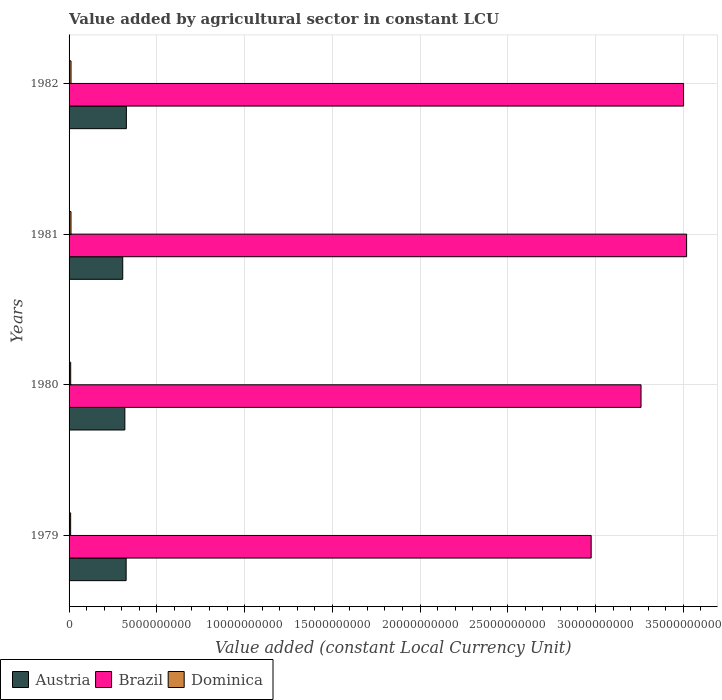How many different coloured bars are there?
Your answer should be compact. 3. How many bars are there on the 4th tick from the top?
Keep it short and to the point. 3. In how many cases, is the number of bars for a given year not equal to the number of legend labels?
Give a very brief answer. 0. What is the value added by agricultural sector in Dominica in 1981?
Ensure brevity in your answer.  1.09e+08. Across all years, what is the maximum value added by agricultural sector in Brazil?
Make the answer very short. 3.52e+1. Across all years, what is the minimum value added by agricultural sector in Dominica?
Your answer should be compact. 8.96e+07. In which year was the value added by agricultural sector in Austria minimum?
Your response must be concise. 1981. What is the total value added by agricultural sector in Brazil in the graph?
Ensure brevity in your answer.  1.33e+11. What is the difference between the value added by agricultural sector in Brazil in 1979 and that in 1980?
Provide a succinct answer. -2.84e+09. What is the difference between the value added by agricultural sector in Brazil in 1980 and the value added by agricultural sector in Dominica in 1979?
Your response must be concise. 3.25e+1. What is the average value added by agricultural sector in Brazil per year?
Your answer should be very brief. 3.31e+1. In the year 1979, what is the difference between the value added by agricultural sector in Brazil and value added by agricultural sector in Austria?
Your answer should be very brief. 2.65e+1. In how many years, is the value added by agricultural sector in Brazil greater than 17000000000 LCU?
Keep it short and to the point. 4. What is the ratio of the value added by agricultural sector in Austria in 1981 to that in 1982?
Make the answer very short. 0.94. Is the value added by agricultural sector in Brazil in 1981 less than that in 1982?
Make the answer very short. No. Is the difference between the value added by agricultural sector in Brazil in 1979 and 1980 greater than the difference between the value added by agricultural sector in Austria in 1979 and 1980?
Make the answer very short. No. What is the difference between the highest and the second highest value added by agricultural sector in Austria?
Your answer should be very brief. 1.25e+07. What is the difference between the highest and the lowest value added by agricultural sector in Dominica?
Make the answer very short. 2.11e+07. What does the 1st bar from the top in 1982 represents?
Keep it short and to the point. Dominica. What does the 2nd bar from the bottom in 1979 represents?
Your response must be concise. Brazil. How many years are there in the graph?
Your response must be concise. 4. Does the graph contain grids?
Keep it short and to the point. Yes. How many legend labels are there?
Ensure brevity in your answer.  3. What is the title of the graph?
Your response must be concise. Value added by agricultural sector in constant LCU. What is the label or title of the X-axis?
Ensure brevity in your answer.  Value added (constant Local Currency Unit). What is the Value added (constant Local Currency Unit) of Austria in 1979?
Make the answer very short. 3.25e+09. What is the Value added (constant Local Currency Unit) in Brazil in 1979?
Your response must be concise. 2.98e+1. What is the Value added (constant Local Currency Unit) of Dominica in 1979?
Provide a short and direct response. 8.96e+07. What is the Value added (constant Local Currency Unit) in Austria in 1980?
Your response must be concise. 3.18e+09. What is the Value added (constant Local Currency Unit) in Brazil in 1980?
Your answer should be compact. 3.26e+1. What is the Value added (constant Local Currency Unit) in Dominica in 1980?
Your response must be concise. 9.17e+07. What is the Value added (constant Local Currency Unit) of Austria in 1981?
Your answer should be very brief. 3.06e+09. What is the Value added (constant Local Currency Unit) in Brazil in 1981?
Your answer should be compact. 3.52e+1. What is the Value added (constant Local Currency Unit) in Dominica in 1981?
Ensure brevity in your answer.  1.09e+08. What is the Value added (constant Local Currency Unit) in Austria in 1982?
Make the answer very short. 3.27e+09. What is the Value added (constant Local Currency Unit) of Brazil in 1982?
Provide a succinct answer. 3.50e+1. What is the Value added (constant Local Currency Unit) in Dominica in 1982?
Your answer should be very brief. 1.11e+08. Across all years, what is the maximum Value added (constant Local Currency Unit) of Austria?
Your response must be concise. 3.27e+09. Across all years, what is the maximum Value added (constant Local Currency Unit) in Brazil?
Offer a terse response. 3.52e+1. Across all years, what is the maximum Value added (constant Local Currency Unit) in Dominica?
Provide a succinct answer. 1.11e+08. Across all years, what is the minimum Value added (constant Local Currency Unit) of Austria?
Provide a succinct answer. 3.06e+09. Across all years, what is the minimum Value added (constant Local Currency Unit) of Brazil?
Your response must be concise. 2.98e+1. Across all years, what is the minimum Value added (constant Local Currency Unit) of Dominica?
Ensure brevity in your answer.  8.96e+07. What is the total Value added (constant Local Currency Unit) in Austria in the graph?
Keep it short and to the point. 1.28e+1. What is the total Value added (constant Local Currency Unit) in Brazil in the graph?
Make the answer very short. 1.33e+11. What is the total Value added (constant Local Currency Unit) of Dominica in the graph?
Provide a short and direct response. 4.01e+08. What is the difference between the Value added (constant Local Currency Unit) in Austria in 1979 and that in 1980?
Provide a short and direct response. 7.33e+07. What is the difference between the Value added (constant Local Currency Unit) in Brazil in 1979 and that in 1980?
Offer a terse response. -2.84e+09. What is the difference between the Value added (constant Local Currency Unit) of Dominica in 1979 and that in 1980?
Make the answer very short. -2.09e+06. What is the difference between the Value added (constant Local Currency Unit) of Austria in 1979 and that in 1981?
Your answer should be compact. 1.94e+08. What is the difference between the Value added (constant Local Currency Unit) in Brazil in 1979 and that in 1981?
Make the answer very short. -5.44e+09. What is the difference between the Value added (constant Local Currency Unit) of Dominica in 1979 and that in 1981?
Ensure brevity in your answer.  -1.97e+07. What is the difference between the Value added (constant Local Currency Unit) in Austria in 1979 and that in 1982?
Offer a terse response. -1.25e+07. What is the difference between the Value added (constant Local Currency Unit) in Brazil in 1979 and that in 1982?
Your answer should be very brief. -5.27e+09. What is the difference between the Value added (constant Local Currency Unit) in Dominica in 1979 and that in 1982?
Offer a very short reply. -2.11e+07. What is the difference between the Value added (constant Local Currency Unit) in Austria in 1980 and that in 1981?
Provide a succinct answer. 1.21e+08. What is the difference between the Value added (constant Local Currency Unit) of Brazil in 1980 and that in 1981?
Provide a succinct answer. -2.60e+09. What is the difference between the Value added (constant Local Currency Unit) in Dominica in 1980 and that in 1981?
Your response must be concise. -1.76e+07. What is the difference between the Value added (constant Local Currency Unit) of Austria in 1980 and that in 1982?
Your response must be concise. -8.58e+07. What is the difference between the Value added (constant Local Currency Unit) of Brazil in 1980 and that in 1982?
Ensure brevity in your answer.  -2.42e+09. What is the difference between the Value added (constant Local Currency Unit) of Dominica in 1980 and that in 1982?
Provide a short and direct response. -1.90e+07. What is the difference between the Value added (constant Local Currency Unit) of Austria in 1981 and that in 1982?
Provide a succinct answer. -2.07e+08. What is the difference between the Value added (constant Local Currency Unit) in Brazil in 1981 and that in 1982?
Make the answer very short. 1.73e+08. What is the difference between the Value added (constant Local Currency Unit) of Dominica in 1981 and that in 1982?
Give a very brief answer. -1.36e+06. What is the difference between the Value added (constant Local Currency Unit) of Austria in 1979 and the Value added (constant Local Currency Unit) of Brazil in 1980?
Make the answer very short. -2.93e+1. What is the difference between the Value added (constant Local Currency Unit) in Austria in 1979 and the Value added (constant Local Currency Unit) in Dominica in 1980?
Give a very brief answer. 3.16e+09. What is the difference between the Value added (constant Local Currency Unit) in Brazil in 1979 and the Value added (constant Local Currency Unit) in Dominica in 1980?
Provide a succinct answer. 2.97e+1. What is the difference between the Value added (constant Local Currency Unit) in Austria in 1979 and the Value added (constant Local Currency Unit) in Brazil in 1981?
Give a very brief answer. -3.19e+1. What is the difference between the Value added (constant Local Currency Unit) of Austria in 1979 and the Value added (constant Local Currency Unit) of Dominica in 1981?
Offer a very short reply. 3.14e+09. What is the difference between the Value added (constant Local Currency Unit) in Brazil in 1979 and the Value added (constant Local Currency Unit) in Dominica in 1981?
Your response must be concise. 2.96e+1. What is the difference between the Value added (constant Local Currency Unit) of Austria in 1979 and the Value added (constant Local Currency Unit) of Brazil in 1982?
Your answer should be very brief. -3.18e+1. What is the difference between the Value added (constant Local Currency Unit) in Austria in 1979 and the Value added (constant Local Currency Unit) in Dominica in 1982?
Provide a short and direct response. 3.14e+09. What is the difference between the Value added (constant Local Currency Unit) in Brazil in 1979 and the Value added (constant Local Currency Unit) in Dominica in 1982?
Give a very brief answer. 2.96e+1. What is the difference between the Value added (constant Local Currency Unit) in Austria in 1980 and the Value added (constant Local Currency Unit) in Brazil in 1981?
Make the answer very short. -3.20e+1. What is the difference between the Value added (constant Local Currency Unit) in Austria in 1980 and the Value added (constant Local Currency Unit) in Dominica in 1981?
Keep it short and to the point. 3.07e+09. What is the difference between the Value added (constant Local Currency Unit) of Brazil in 1980 and the Value added (constant Local Currency Unit) of Dominica in 1981?
Give a very brief answer. 3.25e+1. What is the difference between the Value added (constant Local Currency Unit) of Austria in 1980 and the Value added (constant Local Currency Unit) of Brazil in 1982?
Keep it short and to the point. -3.18e+1. What is the difference between the Value added (constant Local Currency Unit) in Austria in 1980 and the Value added (constant Local Currency Unit) in Dominica in 1982?
Provide a short and direct response. 3.07e+09. What is the difference between the Value added (constant Local Currency Unit) of Brazil in 1980 and the Value added (constant Local Currency Unit) of Dominica in 1982?
Provide a succinct answer. 3.25e+1. What is the difference between the Value added (constant Local Currency Unit) of Austria in 1981 and the Value added (constant Local Currency Unit) of Brazil in 1982?
Your answer should be very brief. -3.20e+1. What is the difference between the Value added (constant Local Currency Unit) in Austria in 1981 and the Value added (constant Local Currency Unit) in Dominica in 1982?
Offer a terse response. 2.95e+09. What is the difference between the Value added (constant Local Currency Unit) of Brazil in 1981 and the Value added (constant Local Currency Unit) of Dominica in 1982?
Your response must be concise. 3.51e+1. What is the average Value added (constant Local Currency Unit) of Austria per year?
Ensure brevity in your answer.  3.19e+09. What is the average Value added (constant Local Currency Unit) in Brazil per year?
Ensure brevity in your answer.  3.31e+1. What is the average Value added (constant Local Currency Unit) of Dominica per year?
Offer a terse response. 1.00e+08. In the year 1979, what is the difference between the Value added (constant Local Currency Unit) in Austria and Value added (constant Local Currency Unit) in Brazil?
Keep it short and to the point. -2.65e+1. In the year 1979, what is the difference between the Value added (constant Local Currency Unit) in Austria and Value added (constant Local Currency Unit) in Dominica?
Keep it short and to the point. 3.16e+09. In the year 1979, what is the difference between the Value added (constant Local Currency Unit) of Brazil and Value added (constant Local Currency Unit) of Dominica?
Your response must be concise. 2.97e+1. In the year 1980, what is the difference between the Value added (constant Local Currency Unit) of Austria and Value added (constant Local Currency Unit) of Brazil?
Keep it short and to the point. -2.94e+1. In the year 1980, what is the difference between the Value added (constant Local Currency Unit) in Austria and Value added (constant Local Currency Unit) in Dominica?
Your answer should be compact. 3.09e+09. In the year 1980, what is the difference between the Value added (constant Local Currency Unit) of Brazil and Value added (constant Local Currency Unit) of Dominica?
Offer a very short reply. 3.25e+1. In the year 1981, what is the difference between the Value added (constant Local Currency Unit) in Austria and Value added (constant Local Currency Unit) in Brazil?
Offer a terse response. -3.21e+1. In the year 1981, what is the difference between the Value added (constant Local Currency Unit) in Austria and Value added (constant Local Currency Unit) in Dominica?
Ensure brevity in your answer.  2.95e+09. In the year 1981, what is the difference between the Value added (constant Local Currency Unit) in Brazil and Value added (constant Local Currency Unit) in Dominica?
Keep it short and to the point. 3.51e+1. In the year 1982, what is the difference between the Value added (constant Local Currency Unit) of Austria and Value added (constant Local Currency Unit) of Brazil?
Ensure brevity in your answer.  -3.18e+1. In the year 1982, what is the difference between the Value added (constant Local Currency Unit) of Austria and Value added (constant Local Currency Unit) of Dominica?
Your answer should be very brief. 3.15e+09. In the year 1982, what is the difference between the Value added (constant Local Currency Unit) in Brazil and Value added (constant Local Currency Unit) in Dominica?
Provide a short and direct response. 3.49e+1. What is the ratio of the Value added (constant Local Currency Unit) of Austria in 1979 to that in 1980?
Provide a succinct answer. 1.02. What is the ratio of the Value added (constant Local Currency Unit) of Brazil in 1979 to that in 1980?
Give a very brief answer. 0.91. What is the ratio of the Value added (constant Local Currency Unit) of Dominica in 1979 to that in 1980?
Provide a succinct answer. 0.98. What is the ratio of the Value added (constant Local Currency Unit) of Austria in 1979 to that in 1981?
Your answer should be very brief. 1.06. What is the ratio of the Value added (constant Local Currency Unit) in Brazil in 1979 to that in 1981?
Provide a short and direct response. 0.85. What is the ratio of the Value added (constant Local Currency Unit) in Dominica in 1979 to that in 1981?
Make the answer very short. 0.82. What is the ratio of the Value added (constant Local Currency Unit) of Brazil in 1979 to that in 1982?
Offer a very short reply. 0.85. What is the ratio of the Value added (constant Local Currency Unit) in Dominica in 1979 to that in 1982?
Your answer should be compact. 0.81. What is the ratio of the Value added (constant Local Currency Unit) in Austria in 1980 to that in 1981?
Make the answer very short. 1.04. What is the ratio of the Value added (constant Local Currency Unit) of Brazil in 1980 to that in 1981?
Offer a terse response. 0.93. What is the ratio of the Value added (constant Local Currency Unit) of Dominica in 1980 to that in 1981?
Your response must be concise. 0.84. What is the ratio of the Value added (constant Local Currency Unit) in Austria in 1980 to that in 1982?
Ensure brevity in your answer.  0.97. What is the ratio of the Value added (constant Local Currency Unit) of Brazil in 1980 to that in 1982?
Offer a terse response. 0.93. What is the ratio of the Value added (constant Local Currency Unit) in Dominica in 1980 to that in 1982?
Make the answer very short. 0.83. What is the ratio of the Value added (constant Local Currency Unit) of Austria in 1981 to that in 1982?
Offer a very short reply. 0.94. What is the difference between the highest and the second highest Value added (constant Local Currency Unit) of Austria?
Offer a very short reply. 1.25e+07. What is the difference between the highest and the second highest Value added (constant Local Currency Unit) of Brazil?
Give a very brief answer. 1.73e+08. What is the difference between the highest and the second highest Value added (constant Local Currency Unit) in Dominica?
Make the answer very short. 1.36e+06. What is the difference between the highest and the lowest Value added (constant Local Currency Unit) of Austria?
Your response must be concise. 2.07e+08. What is the difference between the highest and the lowest Value added (constant Local Currency Unit) of Brazil?
Ensure brevity in your answer.  5.44e+09. What is the difference between the highest and the lowest Value added (constant Local Currency Unit) of Dominica?
Your answer should be very brief. 2.11e+07. 